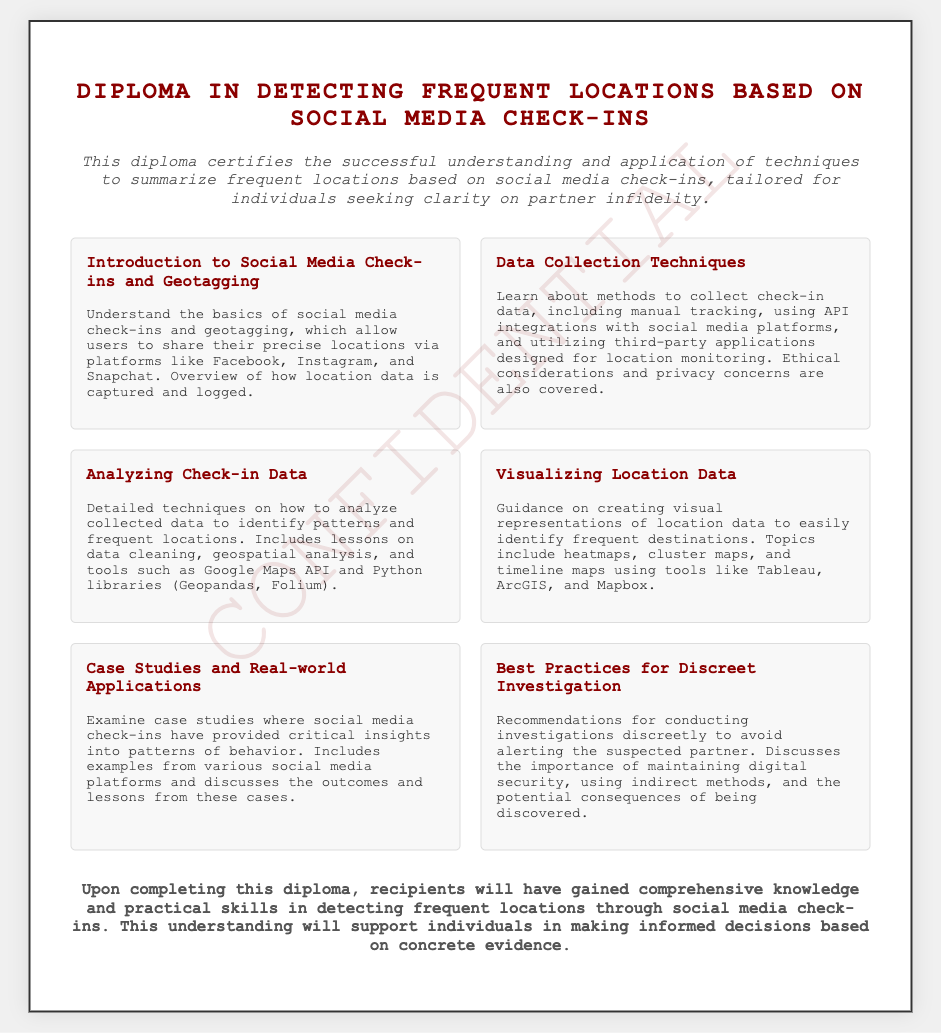What is the title of the diploma? The title appears prominently at the top of the document and is completely stated.
Answer: Diploma in Detecting Frequent Locations Based on Social Media Check-ins How many modules are included in the diploma? The number of modules can be counted in the section where the modules are listed and described.
Answer: Six What is the focus of the course described in the diploma? The main focus is outlined in the description section and speaks to the skills acquired through the program.
Answer: Summarize frequent locations based on social media check-ins Which module discusses ethical considerations? The module that covers this topic is among those listed in the `modules` section.
Answer: Data Collection Techniques What topics are covered in the visualization module? The module mentions specific types of visual representations of location data that will be taught.
Answer: Heatmaps, cluster maps, and timeline maps What do recipients gain after completing the diploma? The conclusion section states the overall benefit of completing the diploma.
Answer: Comprehensive knowledge and practical skills What is the color of the watermark on the document? The color is mentioned as part of the design description within the HTML code.
Answer: Dark red What is highlighted as important in the "Best Practices for Discreet Investigation" module? This module discusses key recommendations that are critical for the topic.
Answer: Digital security 